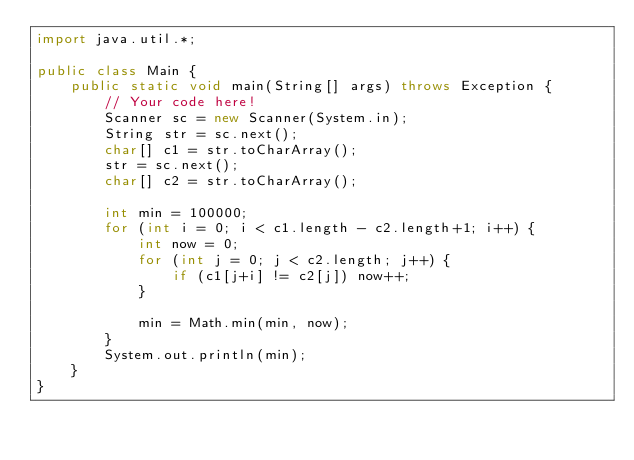Convert code to text. <code><loc_0><loc_0><loc_500><loc_500><_Java_>import java.util.*;

public class Main {
    public static void main(String[] args) throws Exception {
        // Your code here!
        Scanner sc = new Scanner(System.in);
        String str = sc.next();
        char[] c1 = str.toCharArray();
        str = sc.next();
        char[] c2 = str.toCharArray();
        
        int min = 100000;
        for (int i = 0; i < c1.length - c2.length+1; i++) {
            int now = 0;
            for (int j = 0; j < c2.length; j++) {
                if (c1[j+i] != c2[j]) now++;
            }
            
            min = Math.min(min, now);
        }
        System.out.println(min);
    }
}
</code> 